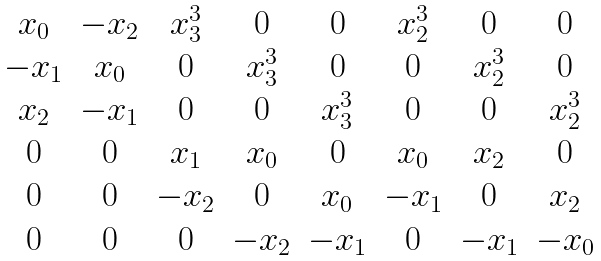<formula> <loc_0><loc_0><loc_500><loc_500>\begin{matrix} x _ { 0 } & - x _ { 2 } & x _ { 3 } ^ { 3 } & 0 & 0 & x _ { 2 } ^ { 3 } & 0 & 0 \\ - x _ { 1 } & x _ { 0 } & 0 & x _ { 3 } ^ { 3 } & 0 & 0 & x _ { 2 } ^ { 3 } & 0 \\ x _ { 2 } & - x _ { 1 } & 0 & 0 & x _ { 3 } ^ { 3 } & 0 & 0 & x _ { 2 } ^ { 3 } \\ 0 & 0 & x _ { 1 } & x _ { 0 } & 0 & x _ { 0 } & x _ { 2 } & 0 \\ 0 & 0 & - x _ { 2 } & 0 & x _ { 0 } & - x _ { 1 } & 0 & x _ { 2 } \\ 0 & 0 & 0 & - x _ { 2 } & - x _ { 1 } & 0 & - x _ { 1 } & - x _ { 0 } \end{matrix}</formula> 